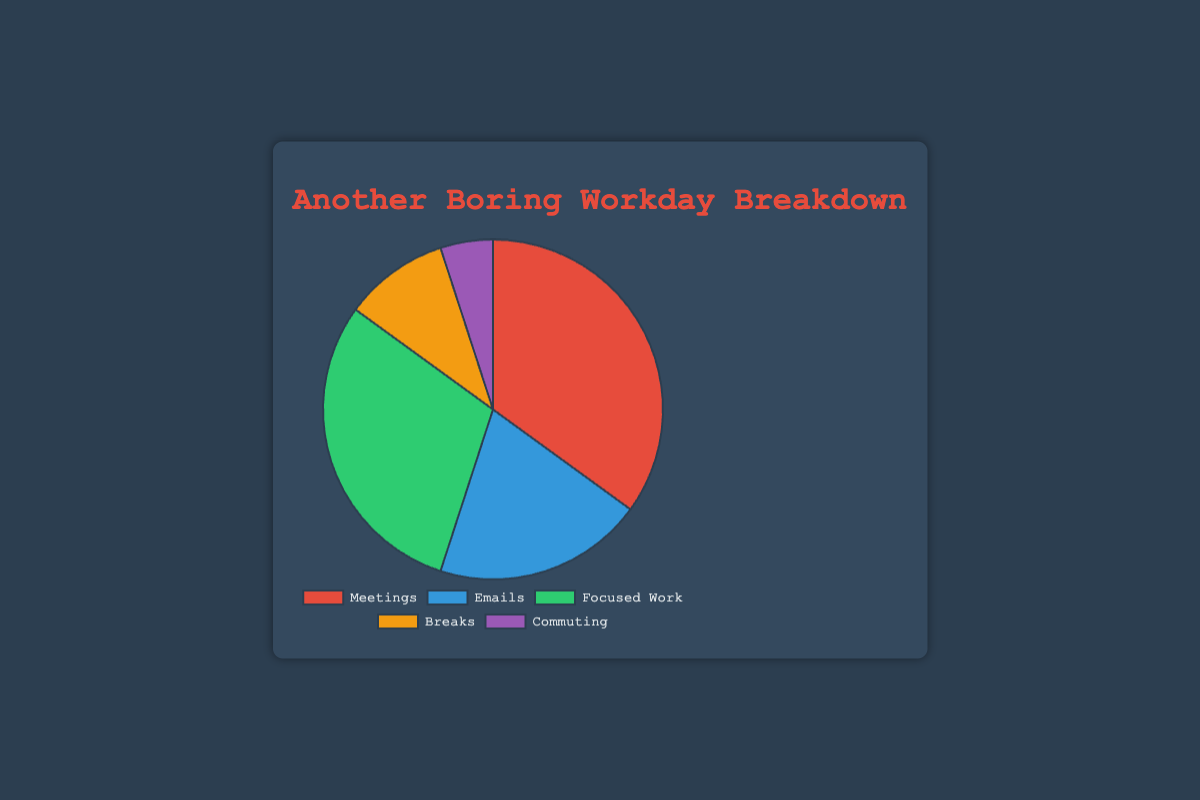What's the largest segment in the pie chart? The segment for Meetings takes up the biggest percentage of the chart at 35%. This can be identified by examining the segment sizes visually in the chart.
Answer: Meetings Which two activities take up the same proportion of the pie chart? By looking at the percentages given in the legend of the chart or on the segments themselves, we see that there are no two activities with the exact same proportion. All activities have different percentages.
Answer: None What's the combined percentage for Emails and Breaks? The percentage for Emails is 20% and for Breaks is 10%. Adding them together, 20% + 10% = 30%.
Answer: 30% Which activity takes up less than 10% of the time? By looking at all segments, Commuting takes up 5% of the time, which is the only segment less than 10%.
Answer: Commuting How much more time is allocated to Meetings compared to Focused Work? Meetings take up 35% of the time, while Focused Work takes up 30%. The difference is 35% - 30% = 5%.
Answer: 5% What's the second smallest segment in the pie chart? The smallest segment is Commuting at 5%. The next smallest segment is Breaks at 10%.
Answer: Breaks Which two activities together take up over half of the pie chart? Meetings account for 35% and Focused Work accounts for 30%. Combined, that's 35% + 30% = 65%, which is over half of the chart.
Answer: Meetings and Focused Work What color is the segment representing Breaks? The chart uses distinct colors for each activity. The segment for Breaks is colored orange.
Answer: Orange What's the ratio of time spent on Emails to time spent on Commuting? Emails take up 20% and Commuting 5%. The ratio is 20:5, which simplifies to 4:1.
Answer: 4:1 